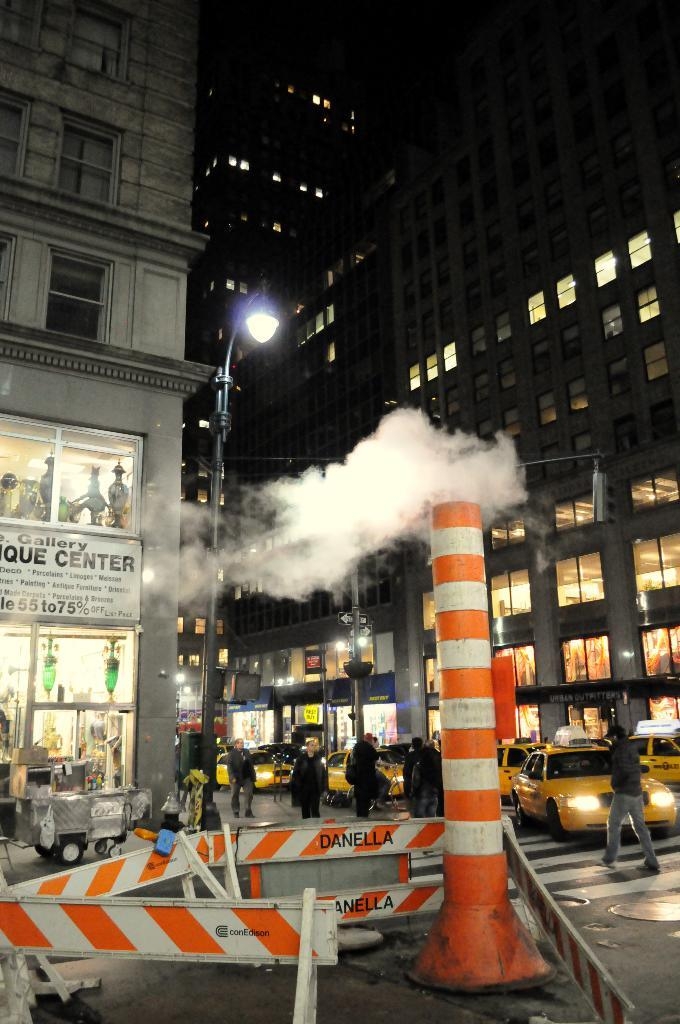What can be seen on the road in the image? There are vehicles and persons on the road in the image. What structures are present in the image? There are poles, lights, and boards in the image. What is visible in the background of the image? There are buildings in the background of the image. What environmental factor is present in the image? There is smoke visible in the image. Can you see a cave in the image? There is no cave present in the image. What type of tray is being used by the persons on the road? There is no tray visible in the image. 